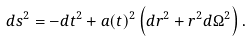<formula> <loc_0><loc_0><loc_500><loc_500>d s ^ { 2 } = - d t ^ { 2 } + a ( t ) ^ { 2 } \left ( d r ^ { 2 } + r ^ { 2 } d \Omega ^ { 2 } \right ) .</formula> 